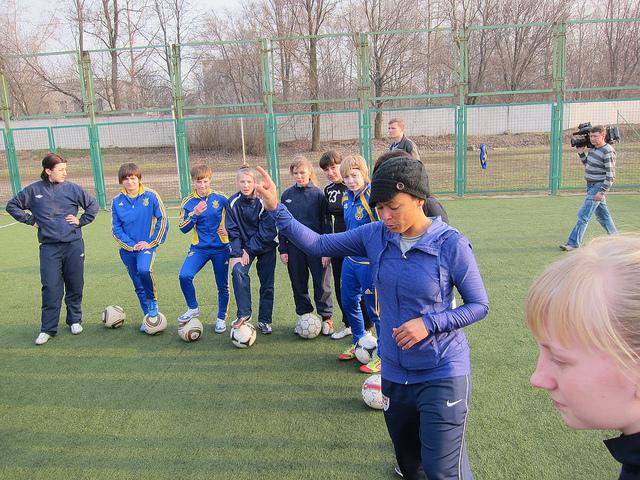What color are most of the people wearing?
Give a very brief answer. Blue. What sport is being played?
Concise answer only. Soccer. How many people in the picture have cameras?
Short answer required. 1. 